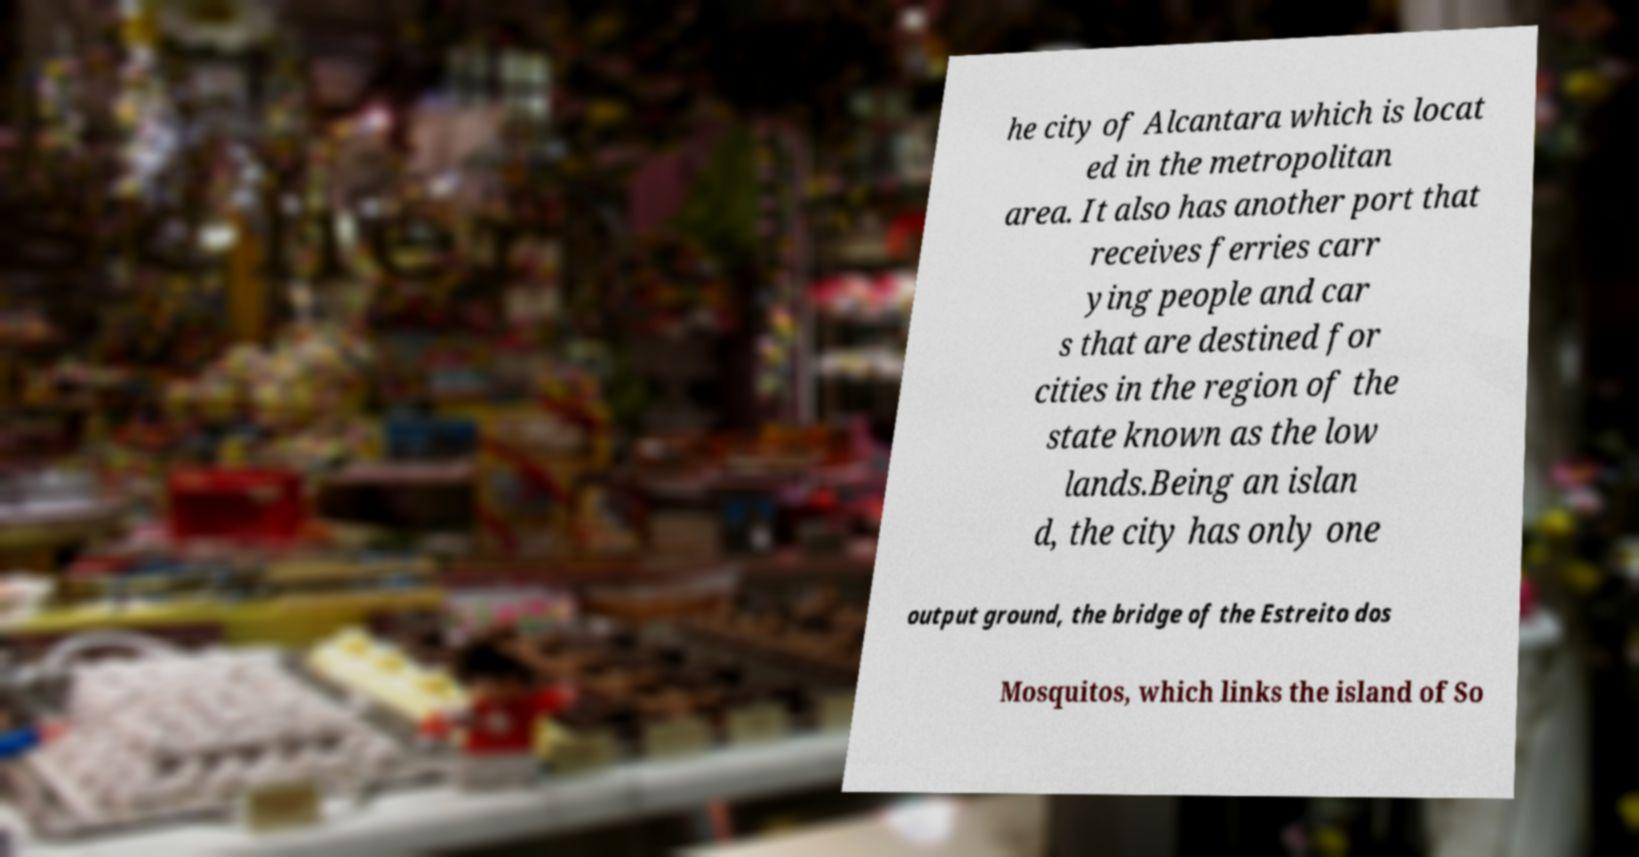Can you read and provide the text displayed in the image?This photo seems to have some interesting text. Can you extract and type it out for me? he city of Alcantara which is locat ed in the metropolitan area. It also has another port that receives ferries carr ying people and car s that are destined for cities in the region of the state known as the low lands.Being an islan d, the city has only one output ground, the bridge of the Estreito dos Mosquitos, which links the island of So 